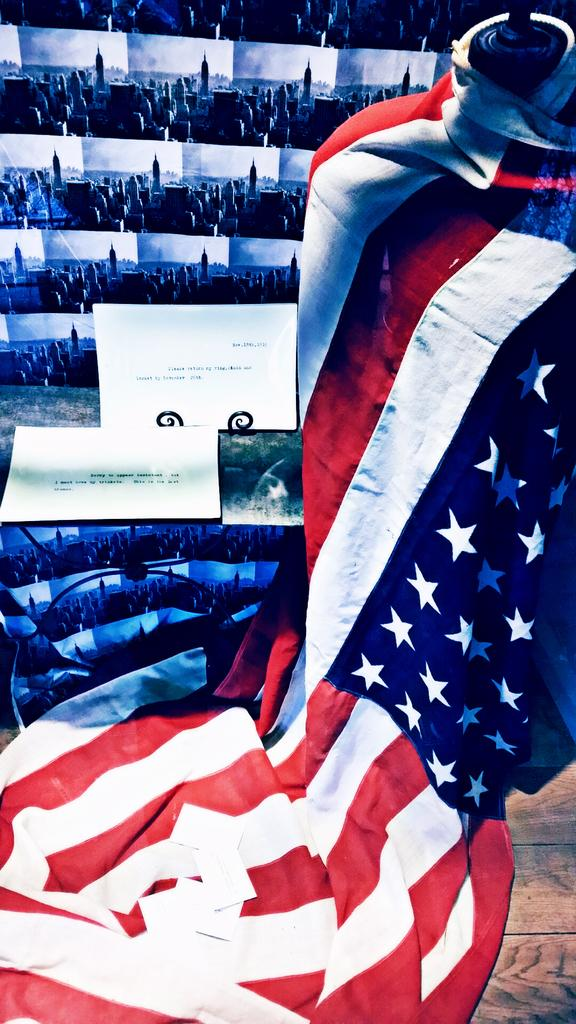What is on the mannequin in the image? There is a flag on a mannequin in the image. What type of images can be seen in the image? There is a group of pictures of buildings in the image. What else is present in the image besides the flag and pictures of buildings? There are boards with text in the image. How does the beetle balance itself on the flag in the image? There is no beetle present in the image, so it cannot be balanced on the flag. What type of joke is written on the boards with text in the image? There is no information about jokes in the image; the boards contain text, but the content is not specified. 